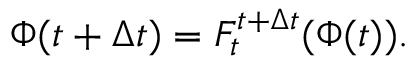<formula> <loc_0><loc_0><loc_500><loc_500>\Phi ( t + \Delta t ) = F _ { t } ^ { t + \Delta t } ( \Phi ( t ) ) .</formula> 